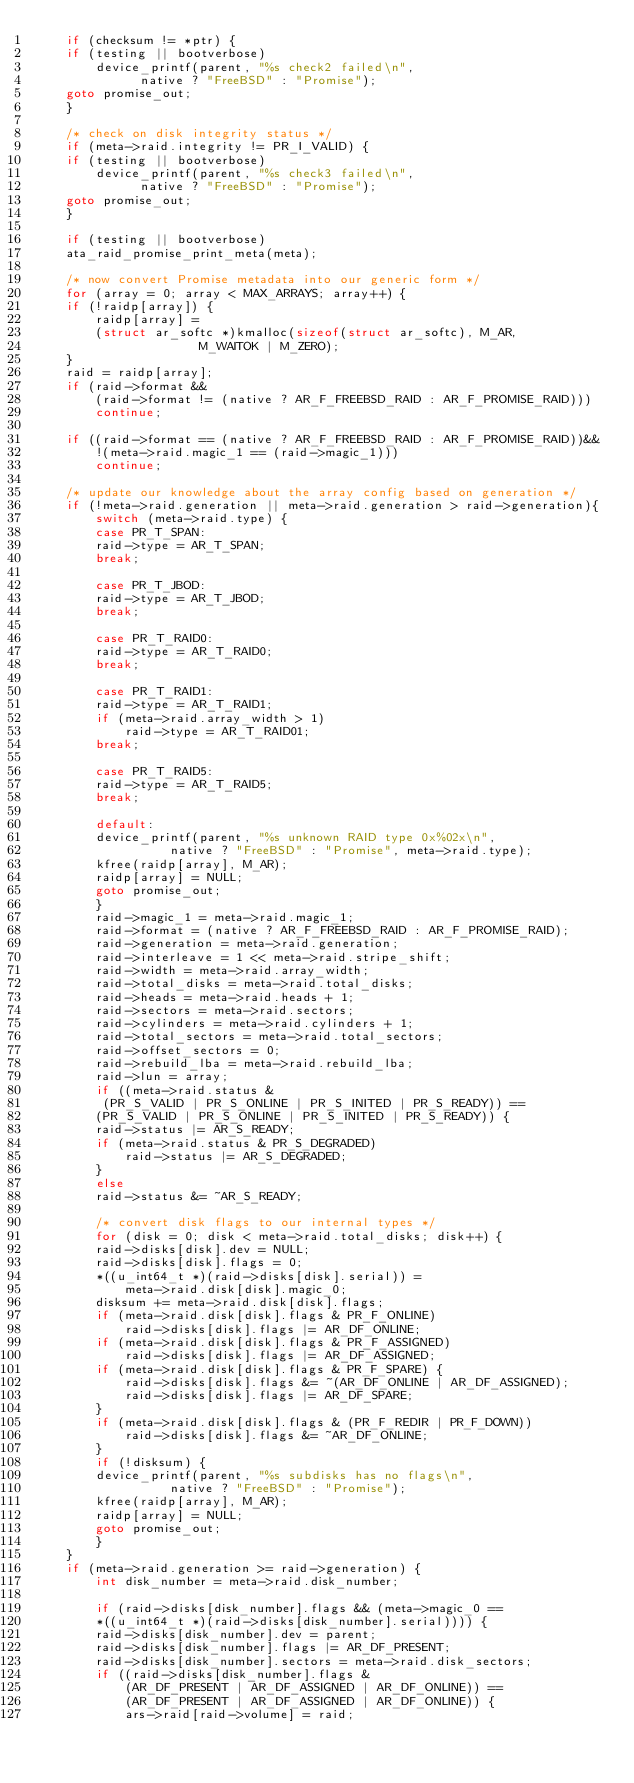<code> <loc_0><loc_0><loc_500><loc_500><_C_>    if (checksum != *ptr) {  
	if (testing || bootverbose)
	    device_printf(parent, "%s check2 failed\n",
			  native ? "FreeBSD" : "Promise");           
	goto promise_out;
    }

    /* check on disk integrity status */
    if (meta->raid.integrity != PR_I_VALID) {
	if (testing || bootverbose)
	    device_printf(parent, "%s check3 failed\n",
			  native ? "FreeBSD" : "Promise");           
	goto promise_out;
    }

    if (testing || bootverbose)
	ata_raid_promise_print_meta(meta);

    /* now convert Promise metadata into our generic form */
    for (array = 0; array < MAX_ARRAYS; array++) {
	if (!raidp[array]) {
	    raidp[array] = 
		(struct ar_softc *)kmalloc(sizeof(struct ar_softc), M_AR,
					  M_WAITOK | M_ZERO);
	}
	raid = raidp[array];
	if (raid->format &&
	    (raid->format != (native ? AR_F_FREEBSD_RAID : AR_F_PROMISE_RAID)))
	    continue;

	if ((raid->format == (native ? AR_F_FREEBSD_RAID : AR_F_PROMISE_RAID))&&
	    !(meta->raid.magic_1 == (raid->magic_1)))
	    continue;

	/* update our knowledge about the array config based on generation */
	if (!meta->raid.generation || meta->raid.generation > raid->generation){
	    switch (meta->raid.type) {
	    case PR_T_SPAN:
		raid->type = AR_T_SPAN;
		break;

	    case PR_T_JBOD:
		raid->type = AR_T_JBOD;
		break;

	    case PR_T_RAID0:
		raid->type = AR_T_RAID0;
		break;

	    case PR_T_RAID1:
		raid->type = AR_T_RAID1;
		if (meta->raid.array_width > 1)
		    raid->type = AR_T_RAID01;
		break;

	    case PR_T_RAID5:
		raid->type = AR_T_RAID5;
		break;

	    default:
		device_printf(parent, "%s unknown RAID type 0x%02x\n",
			      native ? "FreeBSD" : "Promise", meta->raid.type);
		kfree(raidp[array], M_AR);
		raidp[array] = NULL;
		goto promise_out;
	    }
	    raid->magic_1 = meta->raid.magic_1;
	    raid->format = (native ? AR_F_FREEBSD_RAID : AR_F_PROMISE_RAID);
	    raid->generation = meta->raid.generation;
	    raid->interleave = 1 << meta->raid.stripe_shift;
	    raid->width = meta->raid.array_width;
	    raid->total_disks = meta->raid.total_disks;
	    raid->heads = meta->raid.heads + 1;
	    raid->sectors = meta->raid.sectors;
	    raid->cylinders = meta->raid.cylinders + 1;
	    raid->total_sectors = meta->raid.total_sectors;
	    raid->offset_sectors = 0;
	    raid->rebuild_lba = meta->raid.rebuild_lba;
	    raid->lun = array;
	    if ((meta->raid.status &
		 (PR_S_VALID | PR_S_ONLINE | PR_S_INITED | PR_S_READY)) ==
		(PR_S_VALID | PR_S_ONLINE | PR_S_INITED | PR_S_READY)) {
		raid->status |= AR_S_READY;
		if (meta->raid.status & PR_S_DEGRADED)
		    raid->status |= AR_S_DEGRADED;
	    }
	    else
		raid->status &= ~AR_S_READY;

	    /* convert disk flags to our internal types */
	    for (disk = 0; disk < meta->raid.total_disks; disk++) {
		raid->disks[disk].dev = NULL;
		raid->disks[disk].flags = 0;
		*((u_int64_t *)(raid->disks[disk].serial)) = 
		    meta->raid.disk[disk].magic_0;
		disksum += meta->raid.disk[disk].flags;
		if (meta->raid.disk[disk].flags & PR_F_ONLINE)
		    raid->disks[disk].flags |= AR_DF_ONLINE;
		if (meta->raid.disk[disk].flags & PR_F_ASSIGNED)
		    raid->disks[disk].flags |= AR_DF_ASSIGNED;
		if (meta->raid.disk[disk].flags & PR_F_SPARE) {
		    raid->disks[disk].flags &= ~(AR_DF_ONLINE | AR_DF_ASSIGNED);
		    raid->disks[disk].flags |= AR_DF_SPARE;
		}
		if (meta->raid.disk[disk].flags & (PR_F_REDIR | PR_F_DOWN))
		    raid->disks[disk].flags &= ~AR_DF_ONLINE;
	    }
	    if (!disksum) {
		device_printf(parent, "%s subdisks has no flags\n",
			      native ? "FreeBSD" : "Promise");
		kfree(raidp[array], M_AR);
		raidp[array] = NULL;
		goto promise_out;
	    }
	}
	if (meta->raid.generation >= raid->generation) {
	    int disk_number = meta->raid.disk_number;

	    if (raid->disks[disk_number].flags && (meta->magic_0 ==
		*((u_int64_t *)(raid->disks[disk_number].serial)))) {
		raid->disks[disk_number].dev = parent;
		raid->disks[disk_number].flags |= AR_DF_PRESENT;
		raid->disks[disk_number].sectors = meta->raid.disk_sectors;
		if ((raid->disks[disk_number].flags &
		    (AR_DF_PRESENT | AR_DF_ASSIGNED | AR_DF_ONLINE)) ==
		    (AR_DF_PRESENT | AR_DF_ASSIGNED | AR_DF_ONLINE)) {
		    ars->raid[raid->volume] = raid;</code> 